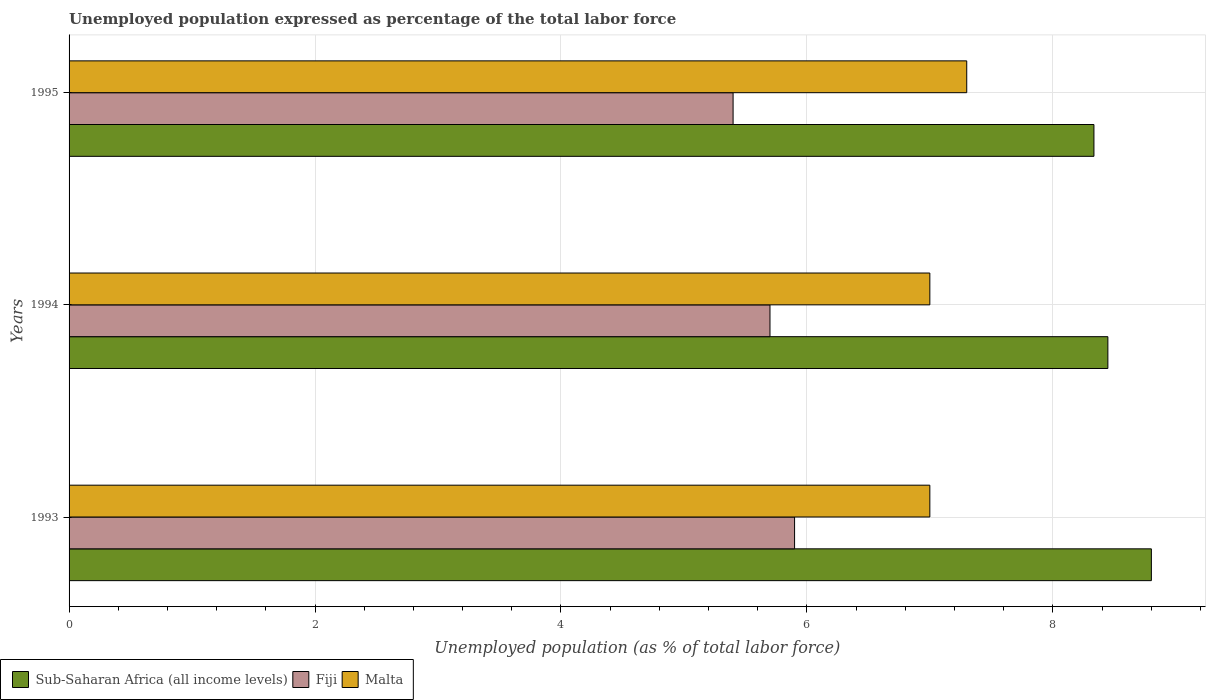Are the number of bars on each tick of the Y-axis equal?
Ensure brevity in your answer.  Yes. How many bars are there on the 1st tick from the bottom?
Keep it short and to the point. 3. In how many cases, is the number of bars for a given year not equal to the number of legend labels?
Your answer should be compact. 0. What is the unemployment in in Malta in 1993?
Your response must be concise. 7. Across all years, what is the maximum unemployment in in Fiji?
Your response must be concise. 5.9. Across all years, what is the minimum unemployment in in Fiji?
Offer a terse response. 5.4. What is the total unemployment in in Fiji in the graph?
Your answer should be compact. 17. What is the difference between the unemployment in in Fiji in 1994 and that in 1995?
Make the answer very short. 0.3. What is the difference between the unemployment in in Sub-Saharan Africa (all income levels) in 1993 and the unemployment in in Malta in 1995?
Provide a short and direct response. 1.5. What is the average unemployment in in Malta per year?
Provide a short and direct response. 7.1. In the year 1993, what is the difference between the unemployment in in Sub-Saharan Africa (all income levels) and unemployment in in Fiji?
Offer a terse response. 2.9. In how many years, is the unemployment in in Sub-Saharan Africa (all income levels) greater than 3.2 %?
Your answer should be compact. 3. What is the ratio of the unemployment in in Sub-Saharan Africa (all income levels) in 1993 to that in 1995?
Your response must be concise. 1.06. Is the unemployment in in Malta in 1994 less than that in 1995?
Give a very brief answer. Yes. What is the difference between the highest and the second highest unemployment in in Sub-Saharan Africa (all income levels)?
Your response must be concise. 0.35. What is the difference between the highest and the lowest unemployment in in Malta?
Give a very brief answer. 0.3. What does the 1st bar from the top in 1995 represents?
Ensure brevity in your answer.  Malta. What does the 3rd bar from the bottom in 1995 represents?
Provide a succinct answer. Malta. Is it the case that in every year, the sum of the unemployment in in Sub-Saharan Africa (all income levels) and unemployment in in Fiji is greater than the unemployment in in Malta?
Offer a very short reply. Yes. How many bars are there?
Offer a very short reply. 9. What is the difference between two consecutive major ticks on the X-axis?
Provide a succinct answer. 2. Are the values on the major ticks of X-axis written in scientific E-notation?
Offer a very short reply. No. What is the title of the graph?
Give a very brief answer. Unemployed population expressed as percentage of the total labor force. What is the label or title of the X-axis?
Make the answer very short. Unemployed population (as % of total labor force). What is the label or title of the Y-axis?
Keep it short and to the point. Years. What is the Unemployed population (as % of total labor force) in Sub-Saharan Africa (all income levels) in 1993?
Offer a very short reply. 8.8. What is the Unemployed population (as % of total labor force) in Fiji in 1993?
Provide a succinct answer. 5.9. What is the Unemployed population (as % of total labor force) in Sub-Saharan Africa (all income levels) in 1994?
Give a very brief answer. 8.45. What is the Unemployed population (as % of total labor force) in Fiji in 1994?
Your response must be concise. 5.7. What is the Unemployed population (as % of total labor force) of Sub-Saharan Africa (all income levels) in 1995?
Make the answer very short. 8.33. What is the Unemployed population (as % of total labor force) of Fiji in 1995?
Offer a very short reply. 5.4. What is the Unemployed population (as % of total labor force) in Malta in 1995?
Ensure brevity in your answer.  7.3. Across all years, what is the maximum Unemployed population (as % of total labor force) in Sub-Saharan Africa (all income levels)?
Make the answer very short. 8.8. Across all years, what is the maximum Unemployed population (as % of total labor force) of Fiji?
Provide a succinct answer. 5.9. Across all years, what is the maximum Unemployed population (as % of total labor force) in Malta?
Ensure brevity in your answer.  7.3. Across all years, what is the minimum Unemployed population (as % of total labor force) of Sub-Saharan Africa (all income levels)?
Your answer should be very brief. 8.33. Across all years, what is the minimum Unemployed population (as % of total labor force) of Fiji?
Offer a very short reply. 5.4. What is the total Unemployed population (as % of total labor force) in Sub-Saharan Africa (all income levels) in the graph?
Ensure brevity in your answer.  25.58. What is the total Unemployed population (as % of total labor force) of Fiji in the graph?
Your answer should be compact. 17. What is the total Unemployed population (as % of total labor force) of Malta in the graph?
Your answer should be very brief. 21.3. What is the difference between the Unemployed population (as % of total labor force) of Sub-Saharan Africa (all income levels) in 1993 and that in 1994?
Offer a terse response. 0.35. What is the difference between the Unemployed population (as % of total labor force) of Fiji in 1993 and that in 1994?
Your response must be concise. 0.2. What is the difference between the Unemployed population (as % of total labor force) in Malta in 1993 and that in 1994?
Provide a short and direct response. 0. What is the difference between the Unemployed population (as % of total labor force) of Sub-Saharan Africa (all income levels) in 1993 and that in 1995?
Ensure brevity in your answer.  0.47. What is the difference between the Unemployed population (as % of total labor force) of Malta in 1993 and that in 1995?
Make the answer very short. -0.3. What is the difference between the Unemployed population (as % of total labor force) of Sub-Saharan Africa (all income levels) in 1994 and that in 1995?
Provide a succinct answer. 0.11. What is the difference between the Unemployed population (as % of total labor force) of Malta in 1994 and that in 1995?
Give a very brief answer. -0.3. What is the difference between the Unemployed population (as % of total labor force) in Sub-Saharan Africa (all income levels) in 1993 and the Unemployed population (as % of total labor force) in Fiji in 1994?
Your answer should be compact. 3.1. What is the difference between the Unemployed population (as % of total labor force) in Sub-Saharan Africa (all income levels) in 1993 and the Unemployed population (as % of total labor force) in Malta in 1994?
Offer a terse response. 1.8. What is the difference between the Unemployed population (as % of total labor force) in Sub-Saharan Africa (all income levels) in 1993 and the Unemployed population (as % of total labor force) in Fiji in 1995?
Give a very brief answer. 3.4. What is the difference between the Unemployed population (as % of total labor force) in Sub-Saharan Africa (all income levels) in 1993 and the Unemployed population (as % of total labor force) in Malta in 1995?
Offer a terse response. 1.5. What is the difference between the Unemployed population (as % of total labor force) in Sub-Saharan Africa (all income levels) in 1994 and the Unemployed population (as % of total labor force) in Fiji in 1995?
Make the answer very short. 3.05. What is the difference between the Unemployed population (as % of total labor force) of Sub-Saharan Africa (all income levels) in 1994 and the Unemployed population (as % of total labor force) of Malta in 1995?
Offer a terse response. 1.15. What is the difference between the Unemployed population (as % of total labor force) of Fiji in 1994 and the Unemployed population (as % of total labor force) of Malta in 1995?
Offer a terse response. -1.6. What is the average Unemployed population (as % of total labor force) in Sub-Saharan Africa (all income levels) per year?
Offer a terse response. 8.53. What is the average Unemployed population (as % of total labor force) in Fiji per year?
Your answer should be compact. 5.67. In the year 1993, what is the difference between the Unemployed population (as % of total labor force) of Sub-Saharan Africa (all income levels) and Unemployed population (as % of total labor force) of Fiji?
Provide a succinct answer. 2.9. In the year 1993, what is the difference between the Unemployed population (as % of total labor force) in Sub-Saharan Africa (all income levels) and Unemployed population (as % of total labor force) in Malta?
Offer a terse response. 1.8. In the year 1993, what is the difference between the Unemployed population (as % of total labor force) in Fiji and Unemployed population (as % of total labor force) in Malta?
Provide a succinct answer. -1.1. In the year 1994, what is the difference between the Unemployed population (as % of total labor force) of Sub-Saharan Africa (all income levels) and Unemployed population (as % of total labor force) of Fiji?
Give a very brief answer. 2.75. In the year 1994, what is the difference between the Unemployed population (as % of total labor force) in Sub-Saharan Africa (all income levels) and Unemployed population (as % of total labor force) in Malta?
Your response must be concise. 1.45. In the year 1995, what is the difference between the Unemployed population (as % of total labor force) of Sub-Saharan Africa (all income levels) and Unemployed population (as % of total labor force) of Fiji?
Offer a very short reply. 2.93. In the year 1995, what is the difference between the Unemployed population (as % of total labor force) of Sub-Saharan Africa (all income levels) and Unemployed population (as % of total labor force) of Malta?
Your response must be concise. 1.03. In the year 1995, what is the difference between the Unemployed population (as % of total labor force) of Fiji and Unemployed population (as % of total labor force) of Malta?
Provide a succinct answer. -1.9. What is the ratio of the Unemployed population (as % of total labor force) of Sub-Saharan Africa (all income levels) in 1993 to that in 1994?
Keep it short and to the point. 1.04. What is the ratio of the Unemployed population (as % of total labor force) in Fiji in 1993 to that in 1994?
Make the answer very short. 1.04. What is the ratio of the Unemployed population (as % of total labor force) of Malta in 1993 to that in 1994?
Make the answer very short. 1. What is the ratio of the Unemployed population (as % of total labor force) in Sub-Saharan Africa (all income levels) in 1993 to that in 1995?
Ensure brevity in your answer.  1.06. What is the ratio of the Unemployed population (as % of total labor force) in Fiji in 1993 to that in 1995?
Provide a succinct answer. 1.09. What is the ratio of the Unemployed population (as % of total labor force) of Malta in 1993 to that in 1995?
Your answer should be compact. 0.96. What is the ratio of the Unemployed population (as % of total labor force) in Sub-Saharan Africa (all income levels) in 1994 to that in 1995?
Give a very brief answer. 1.01. What is the ratio of the Unemployed population (as % of total labor force) of Fiji in 1994 to that in 1995?
Your response must be concise. 1.06. What is the ratio of the Unemployed population (as % of total labor force) of Malta in 1994 to that in 1995?
Ensure brevity in your answer.  0.96. What is the difference between the highest and the second highest Unemployed population (as % of total labor force) in Sub-Saharan Africa (all income levels)?
Offer a very short reply. 0.35. What is the difference between the highest and the lowest Unemployed population (as % of total labor force) in Sub-Saharan Africa (all income levels)?
Offer a very short reply. 0.47. What is the difference between the highest and the lowest Unemployed population (as % of total labor force) in Fiji?
Offer a very short reply. 0.5. What is the difference between the highest and the lowest Unemployed population (as % of total labor force) in Malta?
Make the answer very short. 0.3. 